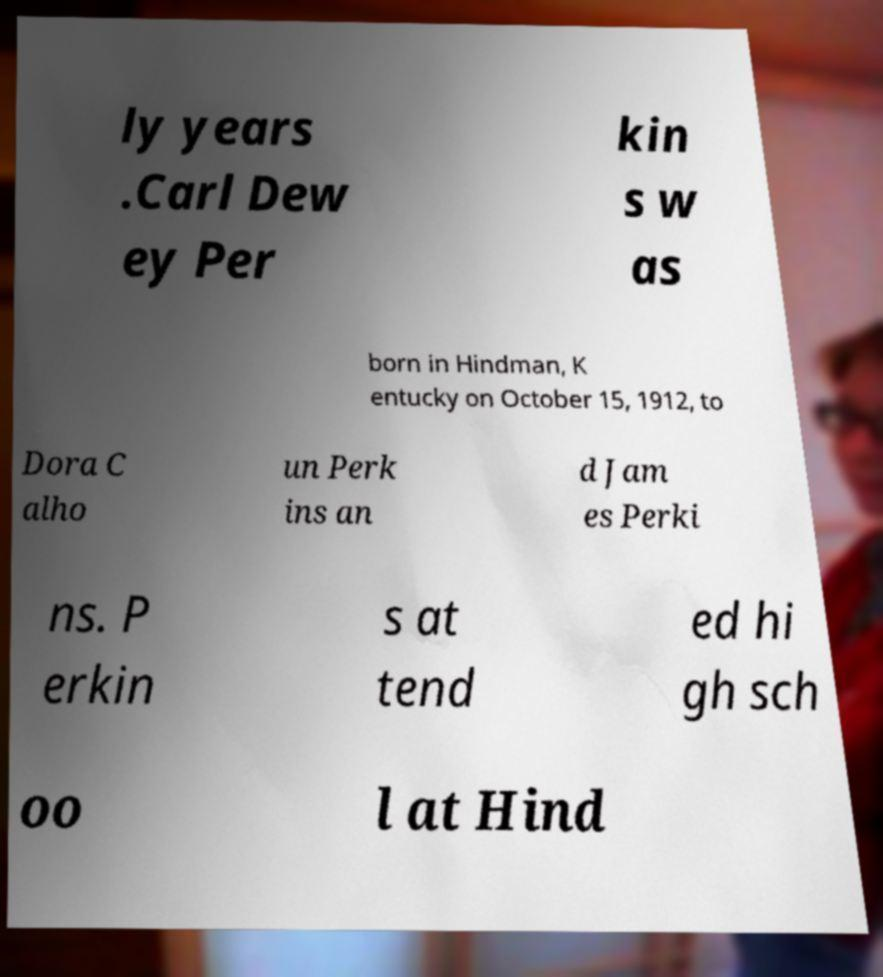There's text embedded in this image that I need extracted. Can you transcribe it verbatim? ly years .Carl Dew ey Per kin s w as born in Hindman, K entucky on October 15, 1912, to Dora C alho un Perk ins an d Jam es Perki ns. P erkin s at tend ed hi gh sch oo l at Hind 